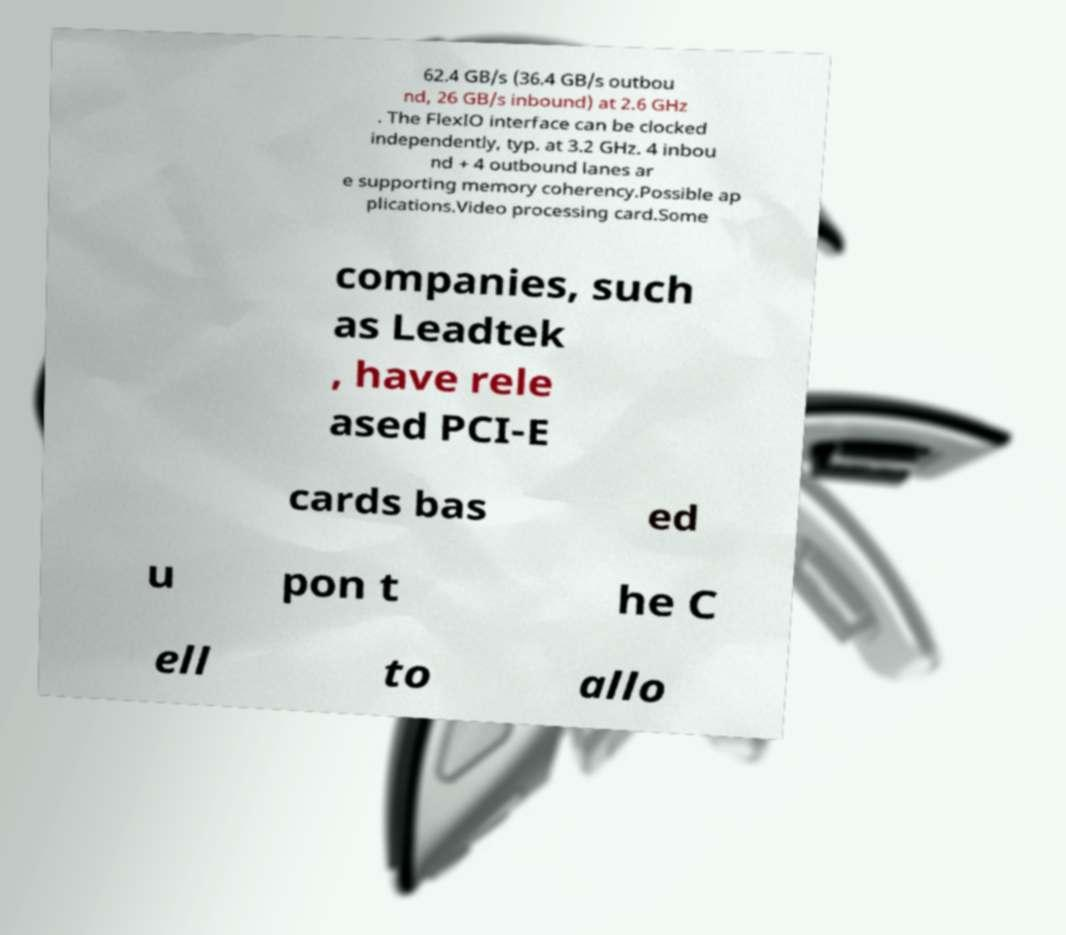Please identify and transcribe the text found in this image. 62.4 GB/s (36.4 GB/s outbou nd, 26 GB/s inbound) at 2.6 GHz . The FlexIO interface can be clocked independently, typ. at 3.2 GHz. 4 inbou nd + 4 outbound lanes ar e supporting memory coherency.Possible ap plications.Video processing card.Some companies, such as Leadtek , have rele ased PCI-E cards bas ed u pon t he C ell to allo 